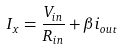Convert formula to latex. <formula><loc_0><loc_0><loc_500><loc_500>I _ { x } = \frac { V _ { i n } } { R _ { i n } } + \beta i _ { o u t }</formula> 